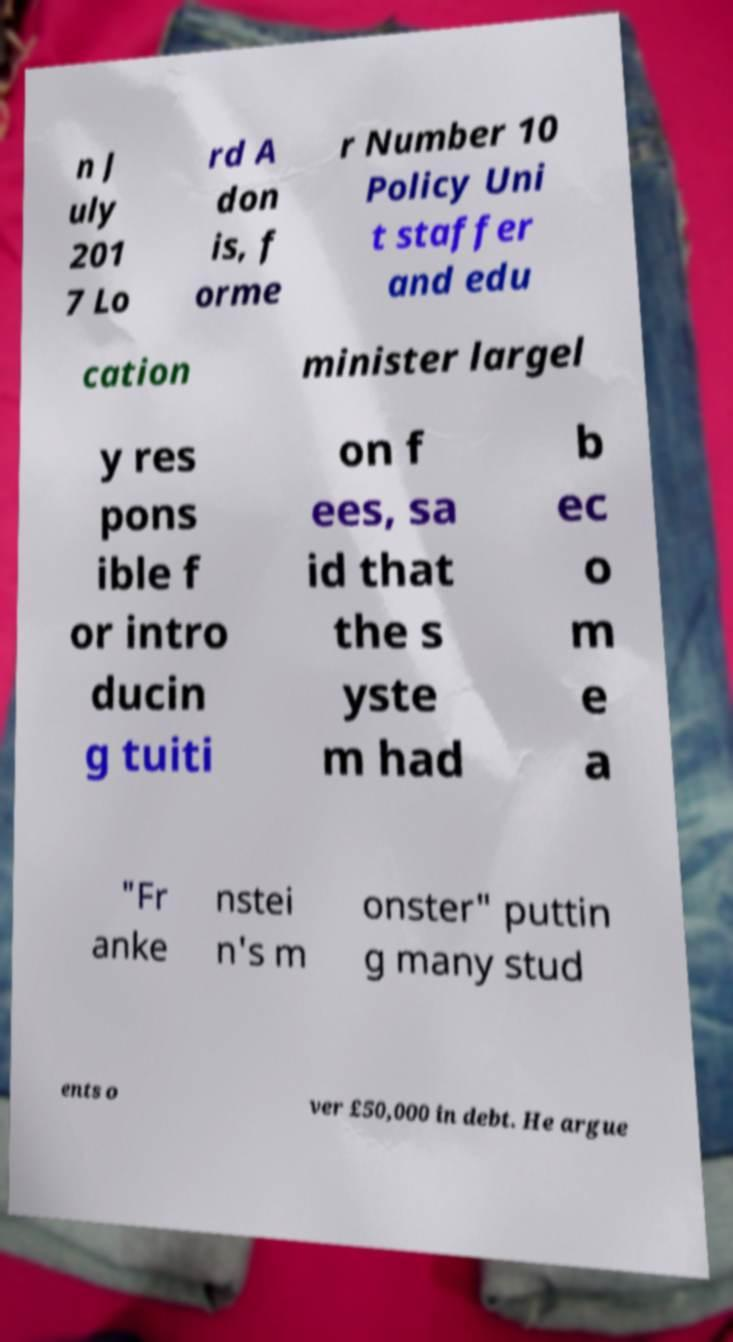Could you assist in decoding the text presented in this image and type it out clearly? n J uly 201 7 Lo rd A don is, f orme r Number 10 Policy Uni t staffer and edu cation minister largel y res pons ible f or intro ducin g tuiti on f ees, sa id that the s yste m had b ec o m e a "Fr anke nstei n's m onster" puttin g many stud ents o ver £50,000 in debt. He argue 